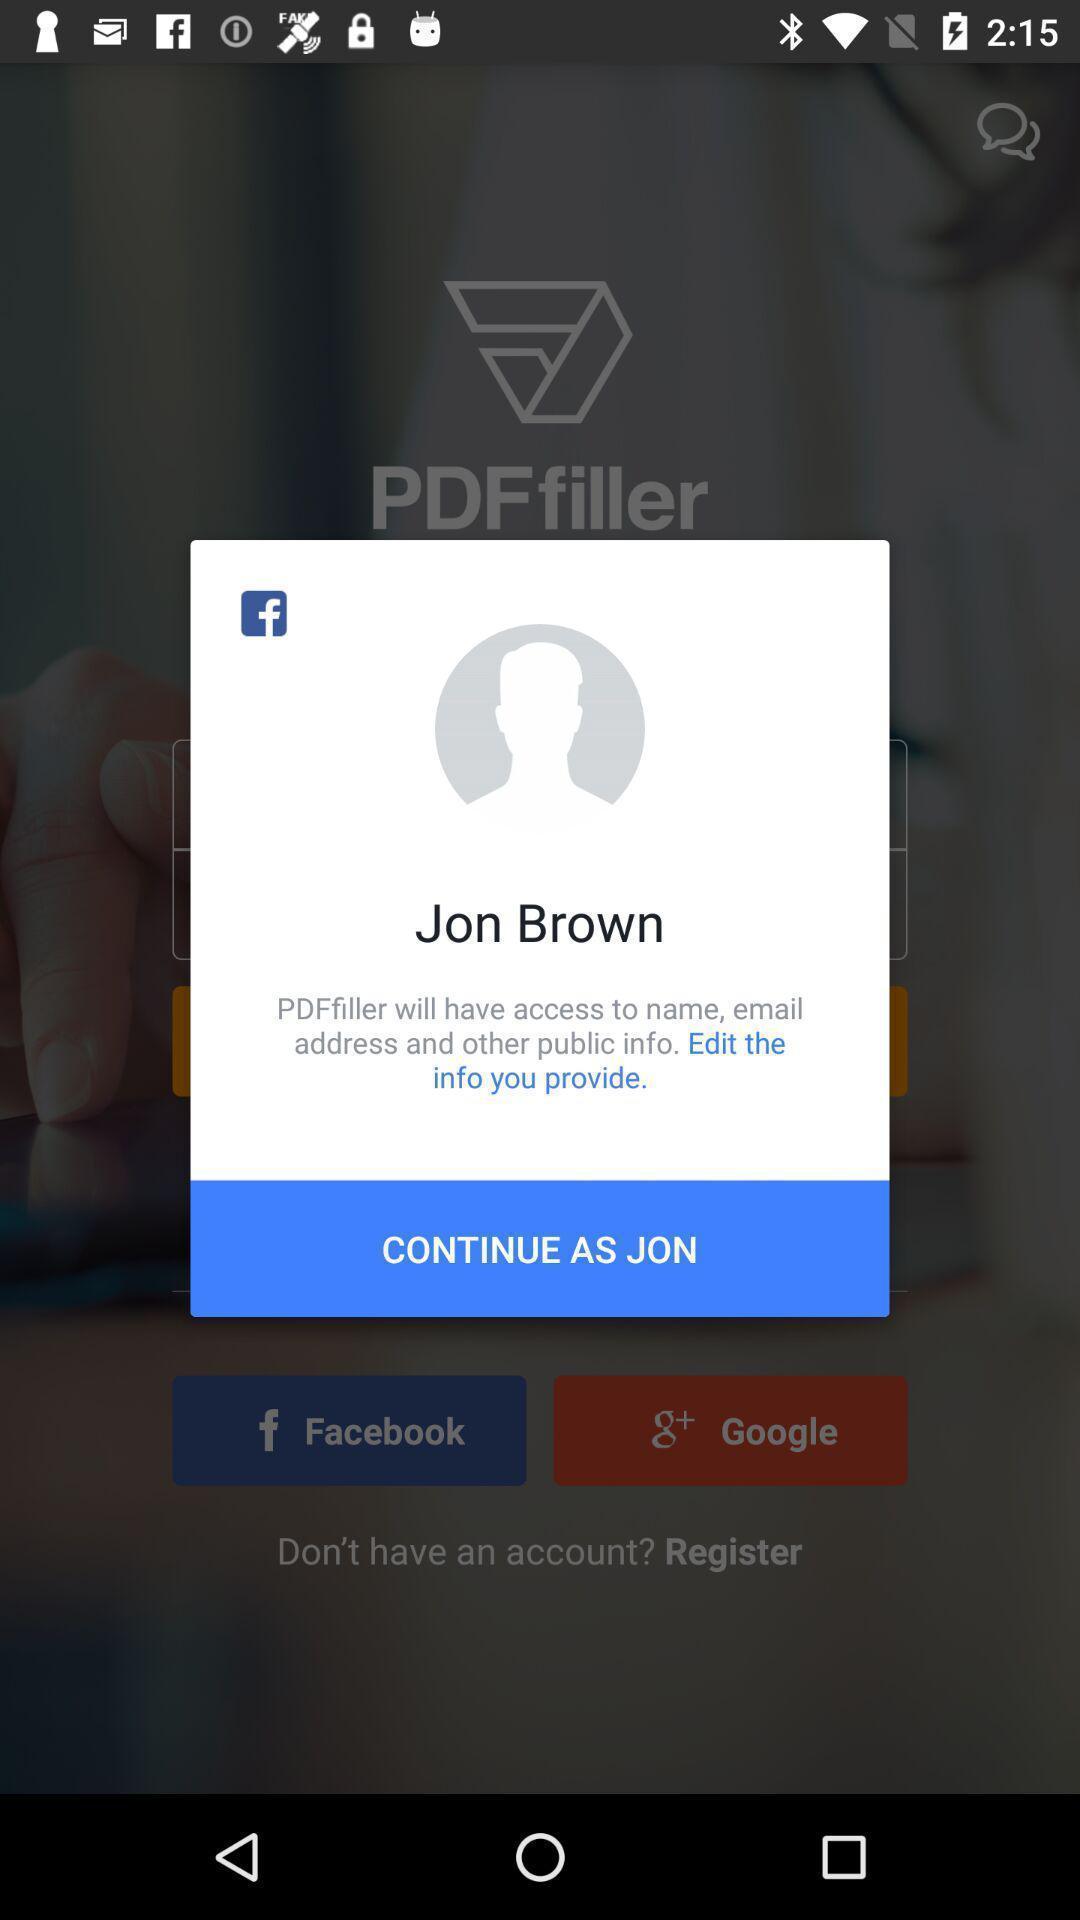What can you discern from this picture? Pop-up shows continue with social app. 